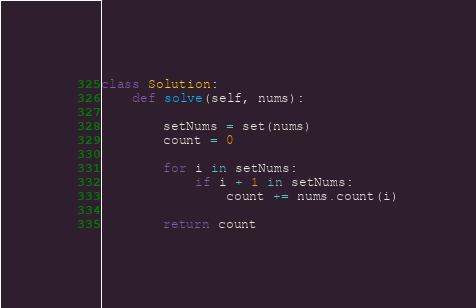<code> <loc_0><loc_0><loc_500><loc_500><_Python_>class Solution:
    def solve(self, nums):

        setNums = set(nums)
        count = 0

        for i in setNums:
            if i + 1 in setNums:
                count += nums.count(i)
        
        return count
</code> 